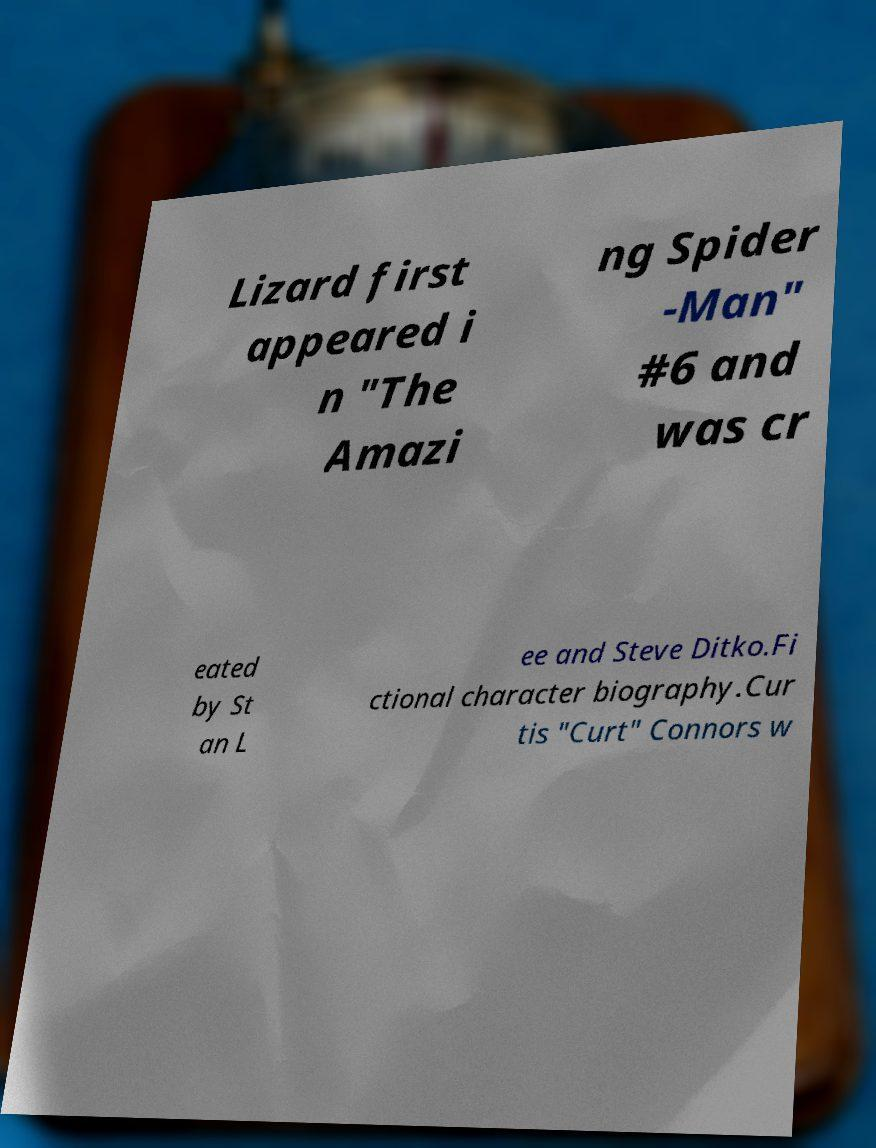Please read and relay the text visible in this image. What does it say? Lizard first appeared i n "The Amazi ng Spider -Man" #6 and was cr eated by St an L ee and Steve Ditko.Fi ctional character biography.Cur tis "Curt" Connors w 